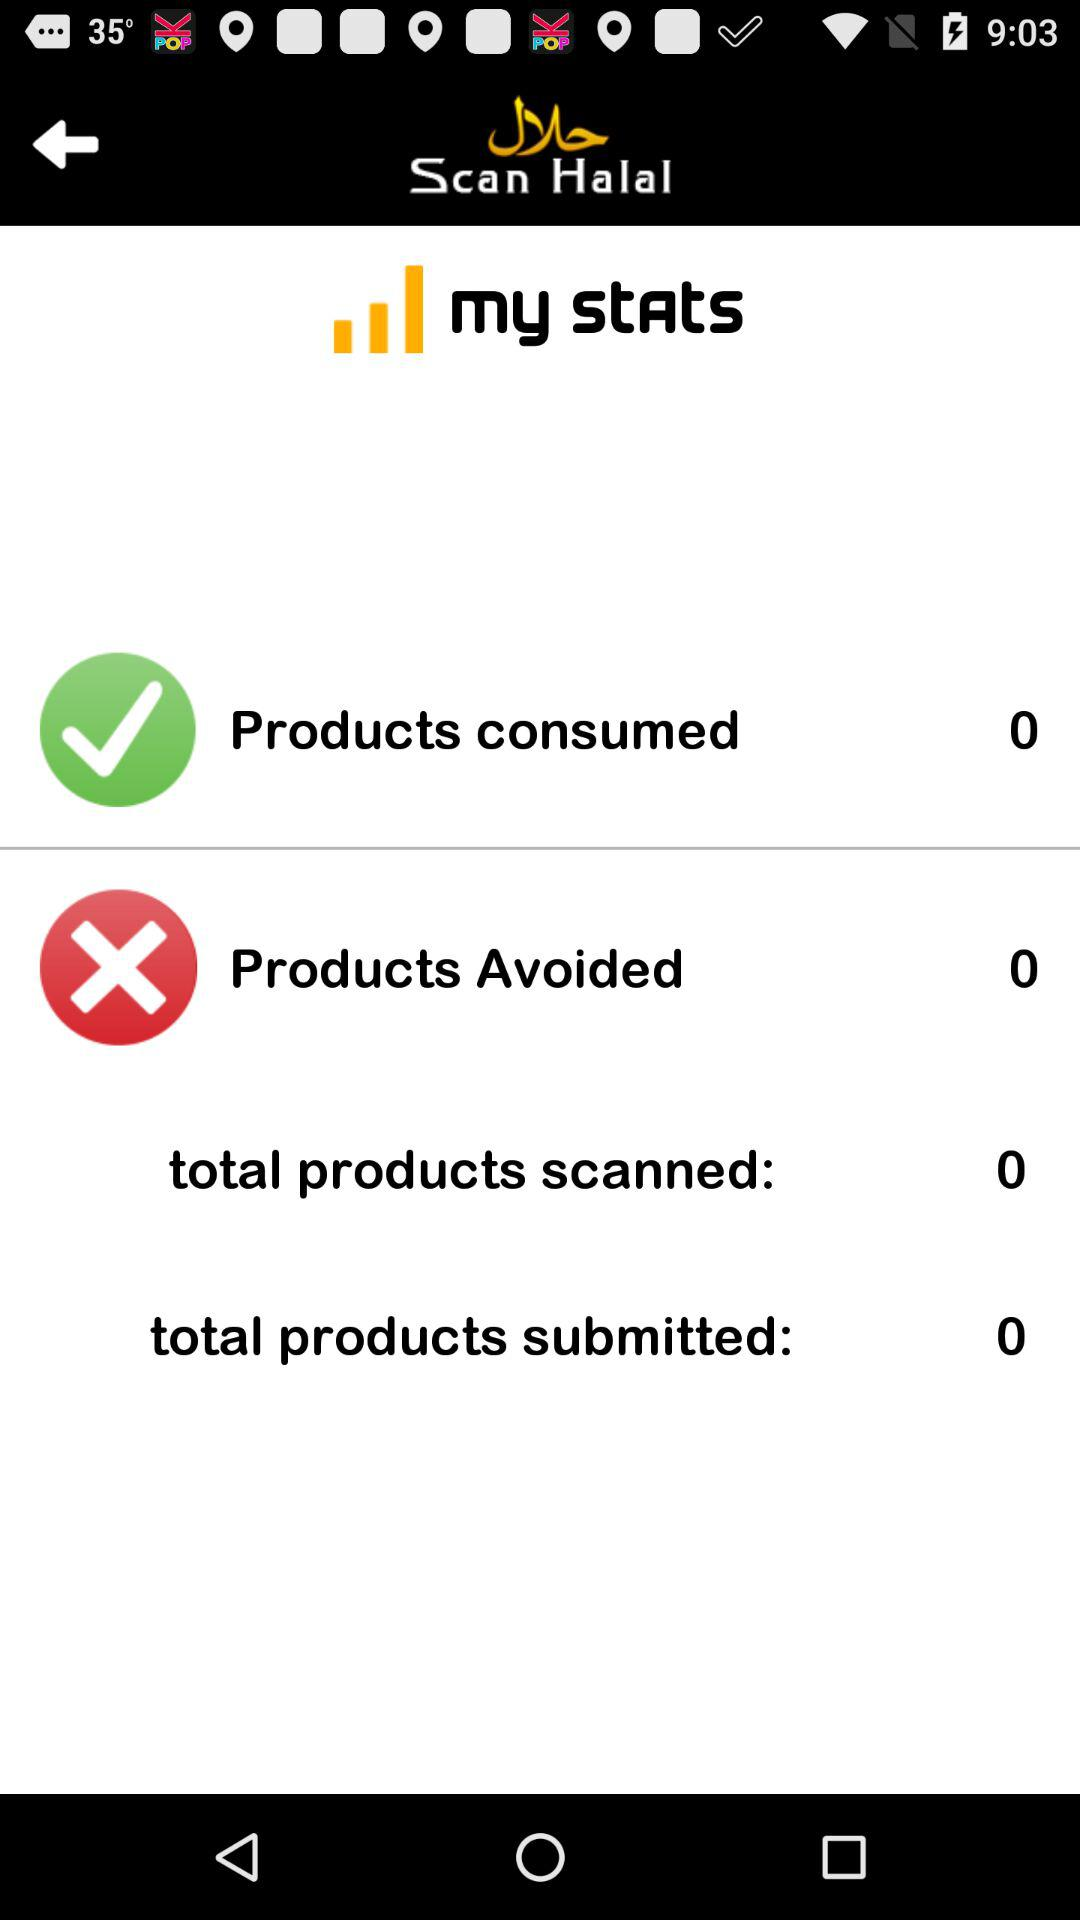What is the total number of scanned products? The total number of scanned products is 0. 